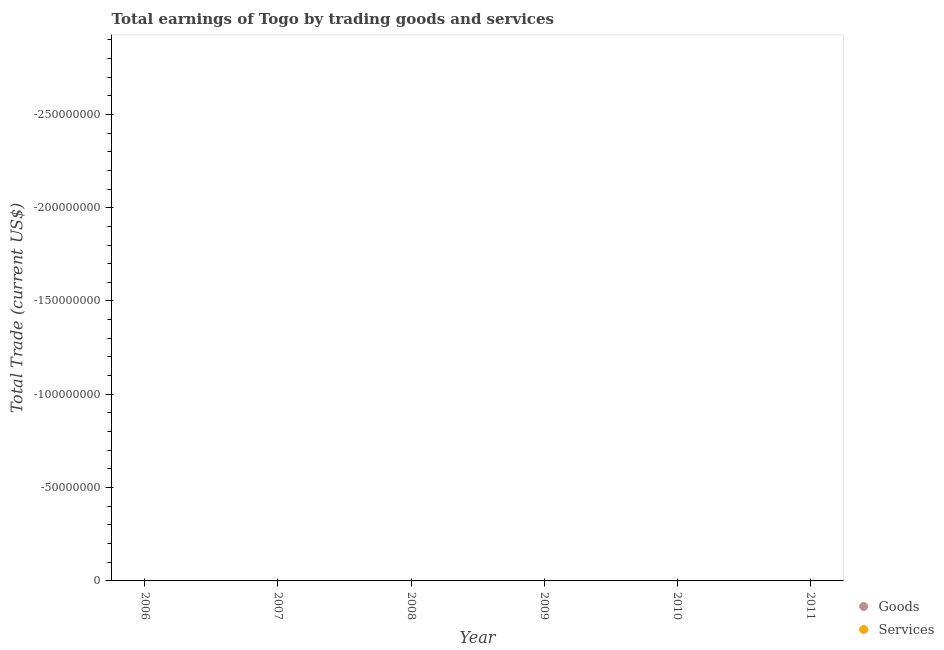How many different coloured dotlines are there?
Ensure brevity in your answer.  0. Is the number of dotlines equal to the number of legend labels?
Offer a very short reply. No. Across all years, what is the minimum amount earned by trading goods?
Your response must be concise. 0. What is the total amount earned by trading goods in the graph?
Make the answer very short. 0. In how many years, is the amount earned by trading goods greater than -190000000 US$?
Your answer should be compact. 0. Does the amount earned by trading services monotonically increase over the years?
Ensure brevity in your answer.  No. Is the amount earned by trading services strictly less than the amount earned by trading goods over the years?
Offer a terse response. No. How many years are there in the graph?
Offer a very short reply. 6. What is the difference between two consecutive major ticks on the Y-axis?
Your answer should be compact. 5.00e+07. Does the graph contain any zero values?
Ensure brevity in your answer.  Yes. How many legend labels are there?
Offer a terse response. 2. What is the title of the graph?
Provide a short and direct response. Total earnings of Togo by trading goods and services. What is the label or title of the X-axis?
Provide a succinct answer. Year. What is the label or title of the Y-axis?
Provide a short and direct response. Total Trade (current US$). What is the Total Trade (current US$) of Goods in 2006?
Offer a very short reply. 0. What is the Total Trade (current US$) of Goods in 2008?
Ensure brevity in your answer.  0. What is the Total Trade (current US$) of Services in 2008?
Offer a very short reply. 0. What is the Total Trade (current US$) in Goods in 2009?
Your answer should be compact. 0. What is the Total Trade (current US$) in Goods in 2010?
Ensure brevity in your answer.  0. What is the Total Trade (current US$) of Services in 2010?
Offer a terse response. 0. What is the Total Trade (current US$) in Services in 2011?
Provide a succinct answer. 0. What is the total Total Trade (current US$) of Goods in the graph?
Make the answer very short. 0. What is the average Total Trade (current US$) of Goods per year?
Offer a very short reply. 0. What is the average Total Trade (current US$) of Services per year?
Your answer should be compact. 0. 